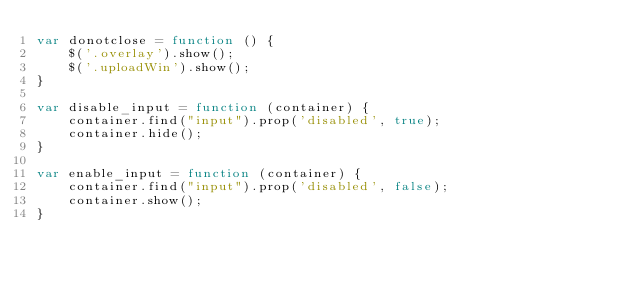<code> <loc_0><loc_0><loc_500><loc_500><_JavaScript_>var donotclose = function () {
    $('.overlay').show();
    $('.uploadWin').show();
}

var disable_input = function (container) {
    container.find("input").prop('disabled', true);
    container.hide();
}

var enable_input = function (container) {
    container.find("input").prop('disabled', false);
    container.show();
}
</code> 